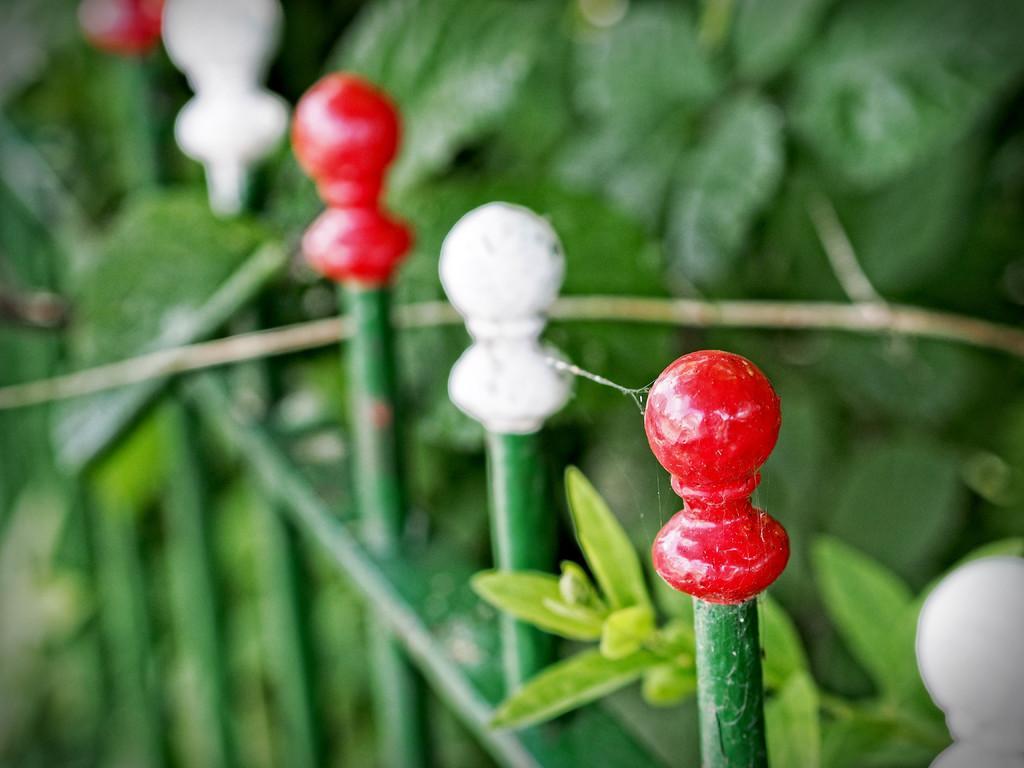In one or two sentences, can you explain what this image depicts? In the picture we can see a railing which is green in color and behind it we can see some plants. 